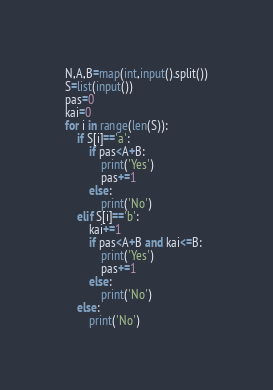<code> <loc_0><loc_0><loc_500><loc_500><_Python_>N,A,B=map(int,input().split())
S=list(input())
pas=0
kai=0
for i in range(len(S)):
    if S[i]=='a':
        if pas<A+B:
            print('Yes')
            pas+=1
        else:
            print('No')
    elif S[i]=='b':
        kai+=1
        if pas<A+B and kai<=B:
            print('Yes')
            pas+=1
        else:
            print('No')
    else:
        print('No')
</code> 